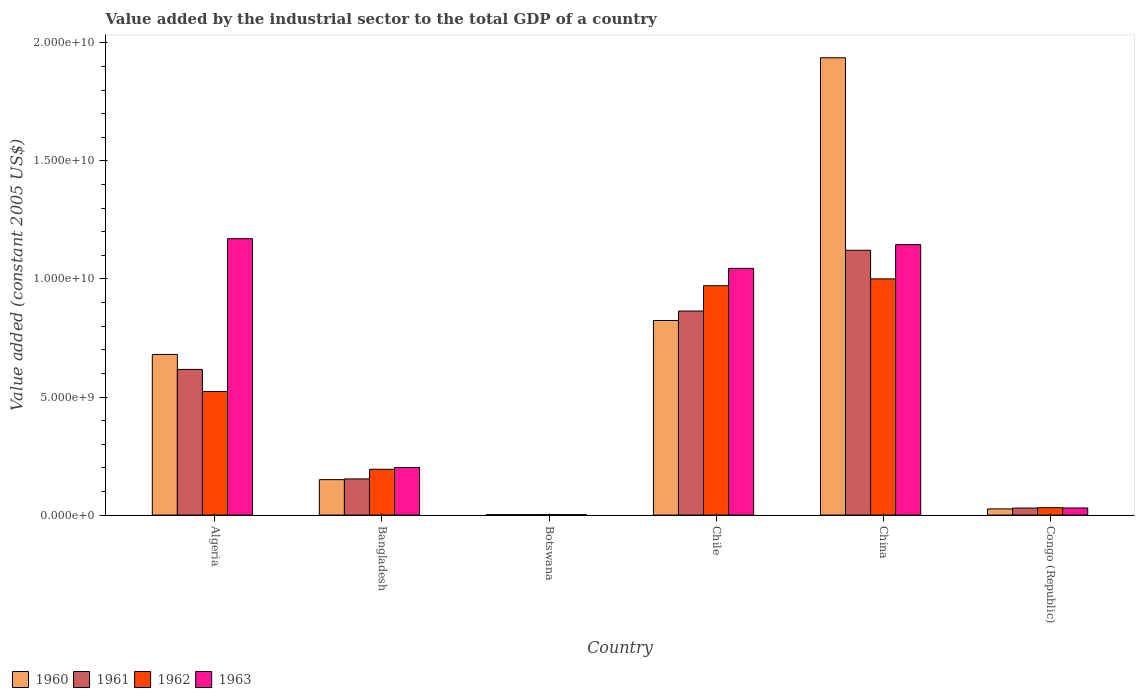How many groups of bars are there?
Provide a succinct answer. 6. Are the number of bars per tick equal to the number of legend labels?
Your answer should be very brief. Yes. Are the number of bars on each tick of the X-axis equal?
Keep it short and to the point. Yes. What is the label of the 2nd group of bars from the left?
Provide a succinct answer. Bangladesh. In how many cases, is the number of bars for a given country not equal to the number of legend labels?
Your response must be concise. 0. What is the value added by the industrial sector in 1961 in Congo (Republic)?
Make the answer very short. 2.98e+08. Across all countries, what is the maximum value added by the industrial sector in 1961?
Offer a very short reply. 1.12e+1. Across all countries, what is the minimum value added by the industrial sector in 1962?
Ensure brevity in your answer.  1.98e+07. In which country was the value added by the industrial sector in 1961 minimum?
Your answer should be very brief. Botswana. What is the total value added by the industrial sector in 1962 in the graph?
Your answer should be compact. 2.72e+1. What is the difference between the value added by the industrial sector in 1961 in Bangladesh and that in Chile?
Your answer should be compact. -7.11e+09. What is the difference between the value added by the industrial sector in 1963 in Botswana and the value added by the industrial sector in 1961 in Congo (Republic)?
Ensure brevity in your answer.  -2.79e+08. What is the average value added by the industrial sector in 1960 per country?
Your answer should be compact. 6.03e+09. What is the difference between the value added by the industrial sector of/in 1962 and value added by the industrial sector of/in 1963 in China?
Offer a very short reply. -1.45e+09. What is the ratio of the value added by the industrial sector in 1961 in Chile to that in China?
Offer a very short reply. 0.77. What is the difference between the highest and the second highest value added by the industrial sector in 1961?
Keep it short and to the point. -2.47e+09. What is the difference between the highest and the lowest value added by the industrial sector in 1962?
Offer a very short reply. 9.98e+09. In how many countries, is the value added by the industrial sector in 1961 greater than the average value added by the industrial sector in 1961 taken over all countries?
Provide a succinct answer. 3. Is it the case that in every country, the sum of the value added by the industrial sector in 1961 and value added by the industrial sector in 1962 is greater than the sum of value added by the industrial sector in 1963 and value added by the industrial sector in 1960?
Offer a very short reply. No. Is it the case that in every country, the sum of the value added by the industrial sector in 1961 and value added by the industrial sector in 1962 is greater than the value added by the industrial sector in 1960?
Your response must be concise. Yes. How many bars are there?
Provide a succinct answer. 24. How many countries are there in the graph?
Your response must be concise. 6. What is the difference between two consecutive major ticks on the Y-axis?
Ensure brevity in your answer.  5.00e+09. Does the graph contain any zero values?
Keep it short and to the point. No. Does the graph contain grids?
Your answer should be compact. No. How are the legend labels stacked?
Keep it short and to the point. Horizontal. What is the title of the graph?
Your response must be concise. Value added by the industrial sector to the total GDP of a country. What is the label or title of the Y-axis?
Keep it short and to the point. Value added (constant 2005 US$). What is the Value added (constant 2005 US$) of 1960 in Algeria?
Give a very brief answer. 6.80e+09. What is the Value added (constant 2005 US$) in 1961 in Algeria?
Your answer should be compact. 6.17e+09. What is the Value added (constant 2005 US$) in 1962 in Algeria?
Your response must be concise. 5.23e+09. What is the Value added (constant 2005 US$) in 1963 in Algeria?
Your response must be concise. 1.17e+1. What is the Value added (constant 2005 US$) in 1960 in Bangladesh?
Offer a terse response. 1.50e+09. What is the Value added (constant 2005 US$) in 1961 in Bangladesh?
Your answer should be compact. 1.53e+09. What is the Value added (constant 2005 US$) in 1962 in Bangladesh?
Your response must be concise. 1.94e+09. What is the Value added (constant 2005 US$) in 1963 in Bangladesh?
Your answer should be compact. 2.01e+09. What is the Value added (constant 2005 US$) of 1960 in Botswana?
Ensure brevity in your answer.  1.96e+07. What is the Value added (constant 2005 US$) in 1961 in Botswana?
Give a very brief answer. 1.92e+07. What is the Value added (constant 2005 US$) in 1962 in Botswana?
Your answer should be compact. 1.98e+07. What is the Value added (constant 2005 US$) in 1963 in Botswana?
Give a very brief answer. 1.83e+07. What is the Value added (constant 2005 US$) of 1960 in Chile?
Your answer should be compact. 8.24e+09. What is the Value added (constant 2005 US$) in 1961 in Chile?
Provide a succinct answer. 8.64e+09. What is the Value added (constant 2005 US$) in 1962 in Chile?
Ensure brevity in your answer.  9.71e+09. What is the Value added (constant 2005 US$) in 1963 in Chile?
Make the answer very short. 1.04e+1. What is the Value added (constant 2005 US$) of 1960 in China?
Give a very brief answer. 1.94e+1. What is the Value added (constant 2005 US$) of 1961 in China?
Your response must be concise. 1.12e+1. What is the Value added (constant 2005 US$) of 1962 in China?
Your answer should be compact. 1.00e+1. What is the Value added (constant 2005 US$) in 1963 in China?
Provide a short and direct response. 1.15e+1. What is the Value added (constant 2005 US$) in 1960 in Congo (Republic)?
Make the answer very short. 2.61e+08. What is the Value added (constant 2005 US$) in 1961 in Congo (Republic)?
Offer a terse response. 2.98e+08. What is the Value added (constant 2005 US$) of 1962 in Congo (Republic)?
Ensure brevity in your answer.  3.12e+08. What is the Value added (constant 2005 US$) of 1963 in Congo (Republic)?
Offer a terse response. 3.00e+08. Across all countries, what is the maximum Value added (constant 2005 US$) of 1960?
Keep it short and to the point. 1.94e+1. Across all countries, what is the maximum Value added (constant 2005 US$) in 1961?
Offer a very short reply. 1.12e+1. Across all countries, what is the maximum Value added (constant 2005 US$) in 1962?
Offer a very short reply. 1.00e+1. Across all countries, what is the maximum Value added (constant 2005 US$) of 1963?
Your answer should be compact. 1.17e+1. Across all countries, what is the minimum Value added (constant 2005 US$) in 1960?
Ensure brevity in your answer.  1.96e+07. Across all countries, what is the minimum Value added (constant 2005 US$) of 1961?
Your answer should be compact. 1.92e+07. Across all countries, what is the minimum Value added (constant 2005 US$) of 1962?
Your answer should be compact. 1.98e+07. Across all countries, what is the minimum Value added (constant 2005 US$) in 1963?
Your answer should be very brief. 1.83e+07. What is the total Value added (constant 2005 US$) in 1960 in the graph?
Make the answer very short. 3.62e+1. What is the total Value added (constant 2005 US$) in 1961 in the graph?
Make the answer very short. 2.79e+1. What is the total Value added (constant 2005 US$) of 1962 in the graph?
Offer a terse response. 2.72e+1. What is the total Value added (constant 2005 US$) in 1963 in the graph?
Your response must be concise. 3.59e+1. What is the difference between the Value added (constant 2005 US$) in 1960 in Algeria and that in Bangladesh?
Your answer should be compact. 5.30e+09. What is the difference between the Value added (constant 2005 US$) in 1961 in Algeria and that in Bangladesh?
Your answer should be very brief. 4.64e+09. What is the difference between the Value added (constant 2005 US$) in 1962 in Algeria and that in Bangladesh?
Your answer should be very brief. 3.29e+09. What is the difference between the Value added (constant 2005 US$) in 1963 in Algeria and that in Bangladesh?
Offer a very short reply. 9.69e+09. What is the difference between the Value added (constant 2005 US$) of 1960 in Algeria and that in Botswana?
Provide a succinct answer. 6.78e+09. What is the difference between the Value added (constant 2005 US$) in 1961 in Algeria and that in Botswana?
Your response must be concise. 6.15e+09. What is the difference between the Value added (constant 2005 US$) of 1962 in Algeria and that in Botswana?
Your answer should be very brief. 5.21e+09. What is the difference between the Value added (constant 2005 US$) in 1963 in Algeria and that in Botswana?
Provide a succinct answer. 1.17e+1. What is the difference between the Value added (constant 2005 US$) of 1960 in Algeria and that in Chile?
Offer a terse response. -1.44e+09. What is the difference between the Value added (constant 2005 US$) of 1961 in Algeria and that in Chile?
Make the answer very short. -2.47e+09. What is the difference between the Value added (constant 2005 US$) in 1962 in Algeria and that in Chile?
Offer a very short reply. -4.48e+09. What is the difference between the Value added (constant 2005 US$) in 1963 in Algeria and that in Chile?
Your answer should be compact. 1.26e+09. What is the difference between the Value added (constant 2005 US$) of 1960 in Algeria and that in China?
Offer a very short reply. -1.26e+1. What is the difference between the Value added (constant 2005 US$) in 1961 in Algeria and that in China?
Ensure brevity in your answer.  -5.05e+09. What is the difference between the Value added (constant 2005 US$) in 1962 in Algeria and that in China?
Ensure brevity in your answer.  -4.77e+09. What is the difference between the Value added (constant 2005 US$) of 1963 in Algeria and that in China?
Provide a succinct answer. 2.51e+08. What is the difference between the Value added (constant 2005 US$) of 1960 in Algeria and that in Congo (Republic)?
Your answer should be compact. 6.54e+09. What is the difference between the Value added (constant 2005 US$) of 1961 in Algeria and that in Congo (Republic)?
Make the answer very short. 5.87e+09. What is the difference between the Value added (constant 2005 US$) in 1962 in Algeria and that in Congo (Republic)?
Your response must be concise. 4.92e+09. What is the difference between the Value added (constant 2005 US$) in 1963 in Algeria and that in Congo (Republic)?
Keep it short and to the point. 1.14e+1. What is the difference between the Value added (constant 2005 US$) of 1960 in Bangladesh and that in Botswana?
Offer a very short reply. 1.48e+09. What is the difference between the Value added (constant 2005 US$) in 1961 in Bangladesh and that in Botswana?
Your answer should be very brief. 1.51e+09. What is the difference between the Value added (constant 2005 US$) in 1962 in Bangladesh and that in Botswana?
Make the answer very short. 1.92e+09. What is the difference between the Value added (constant 2005 US$) of 1963 in Bangladesh and that in Botswana?
Your response must be concise. 2.00e+09. What is the difference between the Value added (constant 2005 US$) in 1960 in Bangladesh and that in Chile?
Provide a short and direct response. -6.74e+09. What is the difference between the Value added (constant 2005 US$) in 1961 in Bangladesh and that in Chile?
Your response must be concise. -7.11e+09. What is the difference between the Value added (constant 2005 US$) in 1962 in Bangladesh and that in Chile?
Make the answer very short. -7.77e+09. What is the difference between the Value added (constant 2005 US$) of 1963 in Bangladesh and that in Chile?
Offer a terse response. -8.43e+09. What is the difference between the Value added (constant 2005 US$) in 1960 in Bangladesh and that in China?
Your answer should be compact. -1.79e+1. What is the difference between the Value added (constant 2005 US$) of 1961 in Bangladesh and that in China?
Provide a short and direct response. -9.68e+09. What is the difference between the Value added (constant 2005 US$) of 1962 in Bangladesh and that in China?
Offer a terse response. -8.06e+09. What is the difference between the Value added (constant 2005 US$) in 1963 in Bangladesh and that in China?
Keep it short and to the point. -9.44e+09. What is the difference between the Value added (constant 2005 US$) in 1960 in Bangladesh and that in Congo (Republic)?
Your answer should be compact. 1.24e+09. What is the difference between the Value added (constant 2005 US$) of 1961 in Bangladesh and that in Congo (Republic)?
Offer a terse response. 1.23e+09. What is the difference between the Value added (constant 2005 US$) of 1962 in Bangladesh and that in Congo (Republic)?
Offer a very short reply. 1.63e+09. What is the difference between the Value added (constant 2005 US$) of 1963 in Bangladesh and that in Congo (Republic)?
Offer a very short reply. 1.71e+09. What is the difference between the Value added (constant 2005 US$) of 1960 in Botswana and that in Chile?
Provide a short and direct response. -8.22e+09. What is the difference between the Value added (constant 2005 US$) of 1961 in Botswana and that in Chile?
Your answer should be compact. -8.62e+09. What is the difference between the Value added (constant 2005 US$) of 1962 in Botswana and that in Chile?
Your response must be concise. -9.69e+09. What is the difference between the Value added (constant 2005 US$) of 1963 in Botswana and that in Chile?
Offer a terse response. -1.04e+1. What is the difference between the Value added (constant 2005 US$) in 1960 in Botswana and that in China?
Keep it short and to the point. -1.93e+1. What is the difference between the Value added (constant 2005 US$) in 1961 in Botswana and that in China?
Give a very brief answer. -1.12e+1. What is the difference between the Value added (constant 2005 US$) of 1962 in Botswana and that in China?
Offer a terse response. -9.98e+09. What is the difference between the Value added (constant 2005 US$) in 1963 in Botswana and that in China?
Make the answer very short. -1.14e+1. What is the difference between the Value added (constant 2005 US$) in 1960 in Botswana and that in Congo (Republic)?
Make the answer very short. -2.42e+08. What is the difference between the Value added (constant 2005 US$) of 1961 in Botswana and that in Congo (Republic)?
Offer a very short reply. -2.78e+08. What is the difference between the Value added (constant 2005 US$) of 1962 in Botswana and that in Congo (Republic)?
Your response must be concise. -2.93e+08. What is the difference between the Value added (constant 2005 US$) in 1963 in Botswana and that in Congo (Republic)?
Your answer should be compact. -2.81e+08. What is the difference between the Value added (constant 2005 US$) of 1960 in Chile and that in China?
Offer a very short reply. -1.11e+1. What is the difference between the Value added (constant 2005 US$) of 1961 in Chile and that in China?
Give a very brief answer. -2.57e+09. What is the difference between the Value added (constant 2005 US$) in 1962 in Chile and that in China?
Give a very brief answer. -2.92e+08. What is the difference between the Value added (constant 2005 US$) of 1963 in Chile and that in China?
Your answer should be very brief. -1.01e+09. What is the difference between the Value added (constant 2005 US$) of 1960 in Chile and that in Congo (Republic)?
Your answer should be very brief. 7.98e+09. What is the difference between the Value added (constant 2005 US$) in 1961 in Chile and that in Congo (Republic)?
Offer a very short reply. 8.34e+09. What is the difference between the Value added (constant 2005 US$) of 1962 in Chile and that in Congo (Republic)?
Ensure brevity in your answer.  9.40e+09. What is the difference between the Value added (constant 2005 US$) of 1963 in Chile and that in Congo (Republic)?
Ensure brevity in your answer.  1.01e+1. What is the difference between the Value added (constant 2005 US$) of 1960 in China and that in Congo (Republic)?
Provide a succinct answer. 1.91e+1. What is the difference between the Value added (constant 2005 US$) of 1961 in China and that in Congo (Republic)?
Ensure brevity in your answer.  1.09e+1. What is the difference between the Value added (constant 2005 US$) of 1962 in China and that in Congo (Republic)?
Give a very brief answer. 9.69e+09. What is the difference between the Value added (constant 2005 US$) of 1963 in China and that in Congo (Republic)?
Make the answer very short. 1.12e+1. What is the difference between the Value added (constant 2005 US$) in 1960 in Algeria and the Value added (constant 2005 US$) in 1961 in Bangladesh?
Give a very brief answer. 5.27e+09. What is the difference between the Value added (constant 2005 US$) in 1960 in Algeria and the Value added (constant 2005 US$) in 1962 in Bangladesh?
Ensure brevity in your answer.  4.86e+09. What is the difference between the Value added (constant 2005 US$) of 1960 in Algeria and the Value added (constant 2005 US$) of 1963 in Bangladesh?
Provide a short and direct response. 4.79e+09. What is the difference between the Value added (constant 2005 US$) of 1961 in Algeria and the Value added (constant 2005 US$) of 1962 in Bangladesh?
Ensure brevity in your answer.  4.23e+09. What is the difference between the Value added (constant 2005 US$) of 1961 in Algeria and the Value added (constant 2005 US$) of 1963 in Bangladesh?
Make the answer very short. 4.15e+09. What is the difference between the Value added (constant 2005 US$) of 1962 in Algeria and the Value added (constant 2005 US$) of 1963 in Bangladesh?
Your answer should be very brief. 3.22e+09. What is the difference between the Value added (constant 2005 US$) of 1960 in Algeria and the Value added (constant 2005 US$) of 1961 in Botswana?
Ensure brevity in your answer.  6.78e+09. What is the difference between the Value added (constant 2005 US$) of 1960 in Algeria and the Value added (constant 2005 US$) of 1962 in Botswana?
Keep it short and to the point. 6.78e+09. What is the difference between the Value added (constant 2005 US$) of 1960 in Algeria and the Value added (constant 2005 US$) of 1963 in Botswana?
Offer a terse response. 6.78e+09. What is the difference between the Value added (constant 2005 US$) of 1961 in Algeria and the Value added (constant 2005 US$) of 1962 in Botswana?
Provide a short and direct response. 6.15e+09. What is the difference between the Value added (constant 2005 US$) in 1961 in Algeria and the Value added (constant 2005 US$) in 1963 in Botswana?
Provide a short and direct response. 6.15e+09. What is the difference between the Value added (constant 2005 US$) in 1962 in Algeria and the Value added (constant 2005 US$) in 1963 in Botswana?
Your answer should be compact. 5.21e+09. What is the difference between the Value added (constant 2005 US$) in 1960 in Algeria and the Value added (constant 2005 US$) in 1961 in Chile?
Make the answer very short. -1.84e+09. What is the difference between the Value added (constant 2005 US$) in 1960 in Algeria and the Value added (constant 2005 US$) in 1962 in Chile?
Ensure brevity in your answer.  -2.91e+09. What is the difference between the Value added (constant 2005 US$) in 1960 in Algeria and the Value added (constant 2005 US$) in 1963 in Chile?
Offer a very short reply. -3.65e+09. What is the difference between the Value added (constant 2005 US$) in 1961 in Algeria and the Value added (constant 2005 US$) in 1962 in Chile?
Keep it short and to the point. -3.54e+09. What is the difference between the Value added (constant 2005 US$) of 1961 in Algeria and the Value added (constant 2005 US$) of 1963 in Chile?
Your answer should be very brief. -4.28e+09. What is the difference between the Value added (constant 2005 US$) in 1962 in Algeria and the Value added (constant 2005 US$) in 1963 in Chile?
Provide a short and direct response. -5.22e+09. What is the difference between the Value added (constant 2005 US$) in 1960 in Algeria and the Value added (constant 2005 US$) in 1961 in China?
Provide a short and direct response. -4.41e+09. What is the difference between the Value added (constant 2005 US$) of 1960 in Algeria and the Value added (constant 2005 US$) of 1962 in China?
Ensure brevity in your answer.  -3.20e+09. What is the difference between the Value added (constant 2005 US$) in 1960 in Algeria and the Value added (constant 2005 US$) in 1963 in China?
Keep it short and to the point. -4.65e+09. What is the difference between the Value added (constant 2005 US$) in 1961 in Algeria and the Value added (constant 2005 US$) in 1962 in China?
Offer a terse response. -3.83e+09. What is the difference between the Value added (constant 2005 US$) in 1961 in Algeria and the Value added (constant 2005 US$) in 1963 in China?
Provide a succinct answer. -5.28e+09. What is the difference between the Value added (constant 2005 US$) of 1962 in Algeria and the Value added (constant 2005 US$) of 1963 in China?
Ensure brevity in your answer.  -6.22e+09. What is the difference between the Value added (constant 2005 US$) of 1960 in Algeria and the Value added (constant 2005 US$) of 1961 in Congo (Republic)?
Offer a very short reply. 6.50e+09. What is the difference between the Value added (constant 2005 US$) in 1960 in Algeria and the Value added (constant 2005 US$) in 1962 in Congo (Republic)?
Ensure brevity in your answer.  6.49e+09. What is the difference between the Value added (constant 2005 US$) of 1960 in Algeria and the Value added (constant 2005 US$) of 1963 in Congo (Republic)?
Your answer should be compact. 6.50e+09. What is the difference between the Value added (constant 2005 US$) in 1961 in Algeria and the Value added (constant 2005 US$) in 1962 in Congo (Republic)?
Provide a succinct answer. 5.86e+09. What is the difference between the Value added (constant 2005 US$) in 1961 in Algeria and the Value added (constant 2005 US$) in 1963 in Congo (Republic)?
Ensure brevity in your answer.  5.87e+09. What is the difference between the Value added (constant 2005 US$) of 1962 in Algeria and the Value added (constant 2005 US$) of 1963 in Congo (Republic)?
Provide a succinct answer. 4.93e+09. What is the difference between the Value added (constant 2005 US$) in 1960 in Bangladesh and the Value added (constant 2005 US$) in 1961 in Botswana?
Offer a very short reply. 1.48e+09. What is the difference between the Value added (constant 2005 US$) of 1960 in Bangladesh and the Value added (constant 2005 US$) of 1962 in Botswana?
Your answer should be compact. 1.48e+09. What is the difference between the Value added (constant 2005 US$) of 1960 in Bangladesh and the Value added (constant 2005 US$) of 1963 in Botswana?
Provide a short and direct response. 1.48e+09. What is the difference between the Value added (constant 2005 US$) of 1961 in Bangladesh and the Value added (constant 2005 US$) of 1962 in Botswana?
Ensure brevity in your answer.  1.51e+09. What is the difference between the Value added (constant 2005 US$) of 1961 in Bangladesh and the Value added (constant 2005 US$) of 1963 in Botswana?
Provide a succinct answer. 1.51e+09. What is the difference between the Value added (constant 2005 US$) in 1962 in Bangladesh and the Value added (constant 2005 US$) in 1963 in Botswana?
Offer a very short reply. 1.92e+09. What is the difference between the Value added (constant 2005 US$) of 1960 in Bangladesh and the Value added (constant 2005 US$) of 1961 in Chile?
Provide a succinct answer. -7.14e+09. What is the difference between the Value added (constant 2005 US$) of 1960 in Bangladesh and the Value added (constant 2005 US$) of 1962 in Chile?
Keep it short and to the point. -8.21e+09. What is the difference between the Value added (constant 2005 US$) of 1960 in Bangladesh and the Value added (constant 2005 US$) of 1963 in Chile?
Provide a succinct answer. -8.95e+09. What is the difference between the Value added (constant 2005 US$) of 1961 in Bangladesh and the Value added (constant 2005 US$) of 1962 in Chile?
Your answer should be very brief. -8.18e+09. What is the difference between the Value added (constant 2005 US$) in 1961 in Bangladesh and the Value added (constant 2005 US$) in 1963 in Chile?
Make the answer very short. -8.92e+09. What is the difference between the Value added (constant 2005 US$) in 1962 in Bangladesh and the Value added (constant 2005 US$) in 1963 in Chile?
Ensure brevity in your answer.  -8.51e+09. What is the difference between the Value added (constant 2005 US$) in 1960 in Bangladesh and the Value added (constant 2005 US$) in 1961 in China?
Offer a terse response. -9.71e+09. What is the difference between the Value added (constant 2005 US$) of 1960 in Bangladesh and the Value added (constant 2005 US$) of 1962 in China?
Your answer should be very brief. -8.50e+09. What is the difference between the Value added (constant 2005 US$) in 1960 in Bangladesh and the Value added (constant 2005 US$) in 1963 in China?
Provide a short and direct response. -9.95e+09. What is the difference between the Value added (constant 2005 US$) in 1961 in Bangladesh and the Value added (constant 2005 US$) in 1962 in China?
Your response must be concise. -8.47e+09. What is the difference between the Value added (constant 2005 US$) in 1961 in Bangladesh and the Value added (constant 2005 US$) in 1963 in China?
Your answer should be compact. -9.92e+09. What is the difference between the Value added (constant 2005 US$) in 1962 in Bangladesh and the Value added (constant 2005 US$) in 1963 in China?
Your answer should be compact. -9.51e+09. What is the difference between the Value added (constant 2005 US$) in 1960 in Bangladesh and the Value added (constant 2005 US$) in 1961 in Congo (Republic)?
Your answer should be compact. 1.20e+09. What is the difference between the Value added (constant 2005 US$) in 1960 in Bangladesh and the Value added (constant 2005 US$) in 1962 in Congo (Republic)?
Give a very brief answer. 1.19e+09. What is the difference between the Value added (constant 2005 US$) in 1960 in Bangladesh and the Value added (constant 2005 US$) in 1963 in Congo (Republic)?
Give a very brief answer. 1.20e+09. What is the difference between the Value added (constant 2005 US$) in 1961 in Bangladesh and the Value added (constant 2005 US$) in 1962 in Congo (Republic)?
Ensure brevity in your answer.  1.22e+09. What is the difference between the Value added (constant 2005 US$) of 1961 in Bangladesh and the Value added (constant 2005 US$) of 1963 in Congo (Republic)?
Keep it short and to the point. 1.23e+09. What is the difference between the Value added (constant 2005 US$) in 1962 in Bangladesh and the Value added (constant 2005 US$) in 1963 in Congo (Republic)?
Your answer should be compact. 1.64e+09. What is the difference between the Value added (constant 2005 US$) in 1960 in Botswana and the Value added (constant 2005 US$) in 1961 in Chile?
Your answer should be compact. -8.62e+09. What is the difference between the Value added (constant 2005 US$) of 1960 in Botswana and the Value added (constant 2005 US$) of 1962 in Chile?
Provide a succinct answer. -9.69e+09. What is the difference between the Value added (constant 2005 US$) in 1960 in Botswana and the Value added (constant 2005 US$) in 1963 in Chile?
Provide a succinct answer. -1.04e+1. What is the difference between the Value added (constant 2005 US$) of 1961 in Botswana and the Value added (constant 2005 US$) of 1962 in Chile?
Provide a succinct answer. -9.69e+09. What is the difference between the Value added (constant 2005 US$) of 1961 in Botswana and the Value added (constant 2005 US$) of 1963 in Chile?
Keep it short and to the point. -1.04e+1. What is the difference between the Value added (constant 2005 US$) in 1962 in Botswana and the Value added (constant 2005 US$) in 1963 in Chile?
Offer a very short reply. -1.04e+1. What is the difference between the Value added (constant 2005 US$) in 1960 in Botswana and the Value added (constant 2005 US$) in 1961 in China?
Offer a terse response. -1.12e+1. What is the difference between the Value added (constant 2005 US$) in 1960 in Botswana and the Value added (constant 2005 US$) in 1962 in China?
Ensure brevity in your answer.  -9.98e+09. What is the difference between the Value added (constant 2005 US$) in 1960 in Botswana and the Value added (constant 2005 US$) in 1963 in China?
Give a very brief answer. -1.14e+1. What is the difference between the Value added (constant 2005 US$) of 1961 in Botswana and the Value added (constant 2005 US$) of 1962 in China?
Give a very brief answer. -9.98e+09. What is the difference between the Value added (constant 2005 US$) in 1961 in Botswana and the Value added (constant 2005 US$) in 1963 in China?
Provide a short and direct response. -1.14e+1. What is the difference between the Value added (constant 2005 US$) of 1962 in Botswana and the Value added (constant 2005 US$) of 1963 in China?
Give a very brief answer. -1.14e+1. What is the difference between the Value added (constant 2005 US$) of 1960 in Botswana and the Value added (constant 2005 US$) of 1961 in Congo (Republic)?
Keep it short and to the point. -2.78e+08. What is the difference between the Value added (constant 2005 US$) of 1960 in Botswana and the Value added (constant 2005 US$) of 1962 in Congo (Republic)?
Offer a terse response. -2.93e+08. What is the difference between the Value added (constant 2005 US$) of 1960 in Botswana and the Value added (constant 2005 US$) of 1963 in Congo (Republic)?
Keep it short and to the point. -2.80e+08. What is the difference between the Value added (constant 2005 US$) of 1961 in Botswana and the Value added (constant 2005 US$) of 1962 in Congo (Republic)?
Give a very brief answer. -2.93e+08. What is the difference between the Value added (constant 2005 US$) in 1961 in Botswana and the Value added (constant 2005 US$) in 1963 in Congo (Republic)?
Make the answer very short. -2.81e+08. What is the difference between the Value added (constant 2005 US$) of 1962 in Botswana and the Value added (constant 2005 US$) of 1963 in Congo (Republic)?
Make the answer very short. -2.80e+08. What is the difference between the Value added (constant 2005 US$) in 1960 in Chile and the Value added (constant 2005 US$) in 1961 in China?
Offer a terse response. -2.97e+09. What is the difference between the Value added (constant 2005 US$) of 1960 in Chile and the Value added (constant 2005 US$) of 1962 in China?
Provide a succinct answer. -1.76e+09. What is the difference between the Value added (constant 2005 US$) of 1960 in Chile and the Value added (constant 2005 US$) of 1963 in China?
Provide a succinct answer. -3.21e+09. What is the difference between the Value added (constant 2005 US$) in 1961 in Chile and the Value added (constant 2005 US$) in 1962 in China?
Make the answer very short. -1.36e+09. What is the difference between the Value added (constant 2005 US$) in 1961 in Chile and the Value added (constant 2005 US$) in 1963 in China?
Provide a succinct answer. -2.81e+09. What is the difference between the Value added (constant 2005 US$) in 1962 in Chile and the Value added (constant 2005 US$) in 1963 in China?
Keep it short and to the point. -1.74e+09. What is the difference between the Value added (constant 2005 US$) of 1960 in Chile and the Value added (constant 2005 US$) of 1961 in Congo (Republic)?
Your answer should be very brief. 7.94e+09. What is the difference between the Value added (constant 2005 US$) in 1960 in Chile and the Value added (constant 2005 US$) in 1962 in Congo (Republic)?
Keep it short and to the point. 7.93e+09. What is the difference between the Value added (constant 2005 US$) of 1960 in Chile and the Value added (constant 2005 US$) of 1963 in Congo (Republic)?
Make the answer very short. 7.94e+09. What is the difference between the Value added (constant 2005 US$) in 1961 in Chile and the Value added (constant 2005 US$) in 1962 in Congo (Republic)?
Your answer should be compact. 8.33e+09. What is the difference between the Value added (constant 2005 US$) in 1961 in Chile and the Value added (constant 2005 US$) in 1963 in Congo (Republic)?
Make the answer very short. 8.34e+09. What is the difference between the Value added (constant 2005 US$) of 1962 in Chile and the Value added (constant 2005 US$) of 1963 in Congo (Republic)?
Keep it short and to the point. 9.41e+09. What is the difference between the Value added (constant 2005 US$) in 1960 in China and the Value added (constant 2005 US$) in 1961 in Congo (Republic)?
Keep it short and to the point. 1.91e+1. What is the difference between the Value added (constant 2005 US$) of 1960 in China and the Value added (constant 2005 US$) of 1962 in Congo (Republic)?
Your answer should be compact. 1.91e+1. What is the difference between the Value added (constant 2005 US$) in 1960 in China and the Value added (constant 2005 US$) in 1963 in Congo (Republic)?
Provide a succinct answer. 1.91e+1. What is the difference between the Value added (constant 2005 US$) of 1961 in China and the Value added (constant 2005 US$) of 1962 in Congo (Republic)?
Make the answer very short. 1.09e+1. What is the difference between the Value added (constant 2005 US$) of 1961 in China and the Value added (constant 2005 US$) of 1963 in Congo (Republic)?
Offer a very short reply. 1.09e+1. What is the difference between the Value added (constant 2005 US$) in 1962 in China and the Value added (constant 2005 US$) in 1963 in Congo (Republic)?
Your answer should be compact. 9.70e+09. What is the average Value added (constant 2005 US$) of 1960 per country?
Give a very brief answer. 6.03e+09. What is the average Value added (constant 2005 US$) of 1961 per country?
Keep it short and to the point. 4.65e+09. What is the average Value added (constant 2005 US$) of 1962 per country?
Offer a very short reply. 4.54e+09. What is the average Value added (constant 2005 US$) of 1963 per country?
Make the answer very short. 5.99e+09. What is the difference between the Value added (constant 2005 US$) in 1960 and Value added (constant 2005 US$) in 1961 in Algeria?
Your response must be concise. 6.34e+08. What is the difference between the Value added (constant 2005 US$) in 1960 and Value added (constant 2005 US$) in 1962 in Algeria?
Give a very brief answer. 1.57e+09. What is the difference between the Value added (constant 2005 US$) in 1960 and Value added (constant 2005 US$) in 1963 in Algeria?
Your response must be concise. -4.90e+09. What is the difference between the Value added (constant 2005 US$) of 1961 and Value added (constant 2005 US$) of 1962 in Algeria?
Make the answer very short. 9.37e+08. What is the difference between the Value added (constant 2005 US$) of 1961 and Value added (constant 2005 US$) of 1963 in Algeria?
Make the answer very short. -5.54e+09. What is the difference between the Value added (constant 2005 US$) of 1962 and Value added (constant 2005 US$) of 1963 in Algeria?
Your response must be concise. -6.47e+09. What is the difference between the Value added (constant 2005 US$) of 1960 and Value added (constant 2005 US$) of 1961 in Bangladesh?
Your answer should be very brief. -3.05e+07. What is the difference between the Value added (constant 2005 US$) in 1960 and Value added (constant 2005 US$) in 1962 in Bangladesh?
Your answer should be very brief. -4.38e+08. What is the difference between the Value added (constant 2005 US$) in 1960 and Value added (constant 2005 US$) in 1963 in Bangladesh?
Give a very brief answer. -5.14e+08. What is the difference between the Value added (constant 2005 US$) in 1961 and Value added (constant 2005 US$) in 1962 in Bangladesh?
Offer a terse response. -4.08e+08. What is the difference between the Value added (constant 2005 US$) in 1961 and Value added (constant 2005 US$) in 1963 in Bangladesh?
Ensure brevity in your answer.  -4.84e+08. What is the difference between the Value added (constant 2005 US$) of 1962 and Value added (constant 2005 US$) of 1963 in Bangladesh?
Provide a succinct answer. -7.60e+07. What is the difference between the Value added (constant 2005 US$) in 1960 and Value added (constant 2005 US$) in 1961 in Botswana?
Your response must be concise. 4.24e+05. What is the difference between the Value added (constant 2005 US$) in 1960 and Value added (constant 2005 US$) in 1962 in Botswana?
Provide a short and direct response. -2.12e+05. What is the difference between the Value added (constant 2005 US$) of 1960 and Value added (constant 2005 US$) of 1963 in Botswana?
Ensure brevity in your answer.  1.27e+06. What is the difference between the Value added (constant 2005 US$) in 1961 and Value added (constant 2005 US$) in 1962 in Botswana?
Your answer should be very brief. -6.36e+05. What is the difference between the Value added (constant 2005 US$) in 1961 and Value added (constant 2005 US$) in 1963 in Botswana?
Keep it short and to the point. 8.48e+05. What is the difference between the Value added (constant 2005 US$) of 1962 and Value added (constant 2005 US$) of 1963 in Botswana?
Make the answer very short. 1.48e+06. What is the difference between the Value added (constant 2005 US$) of 1960 and Value added (constant 2005 US$) of 1961 in Chile?
Offer a terse response. -4.01e+08. What is the difference between the Value added (constant 2005 US$) of 1960 and Value added (constant 2005 US$) of 1962 in Chile?
Provide a short and direct response. -1.47e+09. What is the difference between the Value added (constant 2005 US$) of 1960 and Value added (constant 2005 US$) of 1963 in Chile?
Offer a terse response. -2.21e+09. What is the difference between the Value added (constant 2005 US$) of 1961 and Value added (constant 2005 US$) of 1962 in Chile?
Your response must be concise. -1.07e+09. What is the difference between the Value added (constant 2005 US$) of 1961 and Value added (constant 2005 US$) of 1963 in Chile?
Provide a succinct answer. -1.81e+09. What is the difference between the Value added (constant 2005 US$) in 1962 and Value added (constant 2005 US$) in 1963 in Chile?
Your answer should be very brief. -7.37e+08. What is the difference between the Value added (constant 2005 US$) of 1960 and Value added (constant 2005 US$) of 1961 in China?
Provide a succinct answer. 8.15e+09. What is the difference between the Value added (constant 2005 US$) of 1960 and Value added (constant 2005 US$) of 1962 in China?
Offer a terse response. 9.36e+09. What is the difference between the Value added (constant 2005 US$) of 1960 and Value added (constant 2005 US$) of 1963 in China?
Your answer should be very brief. 7.91e+09. What is the difference between the Value added (constant 2005 US$) in 1961 and Value added (constant 2005 US$) in 1962 in China?
Offer a very short reply. 1.21e+09. What is the difference between the Value added (constant 2005 US$) in 1961 and Value added (constant 2005 US$) in 1963 in China?
Ensure brevity in your answer.  -2.39e+08. What is the difference between the Value added (constant 2005 US$) of 1962 and Value added (constant 2005 US$) of 1963 in China?
Offer a terse response. -1.45e+09. What is the difference between the Value added (constant 2005 US$) in 1960 and Value added (constant 2005 US$) in 1961 in Congo (Republic)?
Provide a short and direct response. -3.63e+07. What is the difference between the Value added (constant 2005 US$) in 1960 and Value added (constant 2005 US$) in 1962 in Congo (Republic)?
Give a very brief answer. -5.10e+07. What is the difference between the Value added (constant 2005 US$) of 1960 and Value added (constant 2005 US$) of 1963 in Congo (Republic)?
Offer a very short reply. -3.84e+07. What is the difference between the Value added (constant 2005 US$) of 1961 and Value added (constant 2005 US$) of 1962 in Congo (Republic)?
Make the answer very short. -1.47e+07. What is the difference between the Value added (constant 2005 US$) of 1961 and Value added (constant 2005 US$) of 1963 in Congo (Republic)?
Your response must be concise. -2.10e+06. What is the difference between the Value added (constant 2005 US$) of 1962 and Value added (constant 2005 US$) of 1963 in Congo (Republic)?
Give a very brief answer. 1.26e+07. What is the ratio of the Value added (constant 2005 US$) of 1960 in Algeria to that in Bangladesh?
Offer a very short reply. 4.53. What is the ratio of the Value added (constant 2005 US$) of 1961 in Algeria to that in Bangladesh?
Your answer should be compact. 4.03. What is the ratio of the Value added (constant 2005 US$) in 1962 in Algeria to that in Bangladesh?
Your response must be concise. 2.7. What is the ratio of the Value added (constant 2005 US$) in 1963 in Algeria to that in Bangladesh?
Offer a terse response. 5.81. What is the ratio of the Value added (constant 2005 US$) of 1960 in Algeria to that in Botswana?
Your answer should be compact. 346.79. What is the ratio of the Value added (constant 2005 US$) in 1961 in Algeria to that in Botswana?
Keep it short and to the point. 321.41. What is the ratio of the Value added (constant 2005 US$) in 1962 in Algeria to that in Botswana?
Your answer should be very brief. 263.85. What is the ratio of the Value added (constant 2005 US$) in 1963 in Algeria to that in Botswana?
Your response must be concise. 638.08. What is the ratio of the Value added (constant 2005 US$) in 1960 in Algeria to that in Chile?
Provide a succinct answer. 0.83. What is the ratio of the Value added (constant 2005 US$) in 1961 in Algeria to that in Chile?
Offer a very short reply. 0.71. What is the ratio of the Value added (constant 2005 US$) in 1962 in Algeria to that in Chile?
Give a very brief answer. 0.54. What is the ratio of the Value added (constant 2005 US$) in 1963 in Algeria to that in Chile?
Offer a very short reply. 1.12. What is the ratio of the Value added (constant 2005 US$) of 1960 in Algeria to that in China?
Provide a succinct answer. 0.35. What is the ratio of the Value added (constant 2005 US$) in 1961 in Algeria to that in China?
Offer a terse response. 0.55. What is the ratio of the Value added (constant 2005 US$) of 1962 in Algeria to that in China?
Your response must be concise. 0.52. What is the ratio of the Value added (constant 2005 US$) of 1963 in Algeria to that in China?
Offer a very short reply. 1.02. What is the ratio of the Value added (constant 2005 US$) in 1960 in Algeria to that in Congo (Republic)?
Your answer should be very brief. 26.02. What is the ratio of the Value added (constant 2005 US$) of 1961 in Algeria to that in Congo (Republic)?
Your answer should be compact. 20.72. What is the ratio of the Value added (constant 2005 US$) of 1962 in Algeria to that in Congo (Republic)?
Your answer should be compact. 16.75. What is the ratio of the Value added (constant 2005 US$) of 1963 in Algeria to that in Congo (Republic)?
Ensure brevity in your answer.  39.05. What is the ratio of the Value added (constant 2005 US$) of 1960 in Bangladesh to that in Botswana?
Your answer should be very brief. 76.48. What is the ratio of the Value added (constant 2005 US$) of 1961 in Bangladesh to that in Botswana?
Provide a succinct answer. 79.76. What is the ratio of the Value added (constant 2005 US$) of 1962 in Bangladesh to that in Botswana?
Keep it short and to the point. 97.78. What is the ratio of the Value added (constant 2005 US$) in 1963 in Bangladesh to that in Botswana?
Make the answer very short. 109.83. What is the ratio of the Value added (constant 2005 US$) of 1960 in Bangladesh to that in Chile?
Provide a short and direct response. 0.18. What is the ratio of the Value added (constant 2005 US$) in 1961 in Bangladesh to that in Chile?
Offer a terse response. 0.18. What is the ratio of the Value added (constant 2005 US$) of 1962 in Bangladesh to that in Chile?
Offer a very short reply. 0.2. What is the ratio of the Value added (constant 2005 US$) of 1963 in Bangladesh to that in Chile?
Your answer should be very brief. 0.19. What is the ratio of the Value added (constant 2005 US$) in 1960 in Bangladesh to that in China?
Make the answer very short. 0.08. What is the ratio of the Value added (constant 2005 US$) of 1961 in Bangladesh to that in China?
Your answer should be very brief. 0.14. What is the ratio of the Value added (constant 2005 US$) in 1962 in Bangladesh to that in China?
Provide a short and direct response. 0.19. What is the ratio of the Value added (constant 2005 US$) of 1963 in Bangladesh to that in China?
Provide a short and direct response. 0.18. What is the ratio of the Value added (constant 2005 US$) of 1960 in Bangladesh to that in Congo (Republic)?
Offer a very short reply. 5.74. What is the ratio of the Value added (constant 2005 US$) of 1961 in Bangladesh to that in Congo (Republic)?
Your response must be concise. 5.14. What is the ratio of the Value added (constant 2005 US$) of 1962 in Bangladesh to that in Congo (Republic)?
Provide a short and direct response. 6.21. What is the ratio of the Value added (constant 2005 US$) in 1963 in Bangladesh to that in Congo (Republic)?
Make the answer very short. 6.72. What is the ratio of the Value added (constant 2005 US$) of 1960 in Botswana to that in Chile?
Make the answer very short. 0. What is the ratio of the Value added (constant 2005 US$) of 1961 in Botswana to that in Chile?
Your answer should be compact. 0. What is the ratio of the Value added (constant 2005 US$) of 1962 in Botswana to that in Chile?
Offer a very short reply. 0. What is the ratio of the Value added (constant 2005 US$) of 1963 in Botswana to that in Chile?
Keep it short and to the point. 0. What is the ratio of the Value added (constant 2005 US$) in 1960 in Botswana to that in China?
Provide a succinct answer. 0. What is the ratio of the Value added (constant 2005 US$) in 1961 in Botswana to that in China?
Offer a terse response. 0. What is the ratio of the Value added (constant 2005 US$) of 1962 in Botswana to that in China?
Offer a terse response. 0. What is the ratio of the Value added (constant 2005 US$) of 1963 in Botswana to that in China?
Make the answer very short. 0. What is the ratio of the Value added (constant 2005 US$) of 1960 in Botswana to that in Congo (Republic)?
Offer a very short reply. 0.07. What is the ratio of the Value added (constant 2005 US$) of 1961 in Botswana to that in Congo (Republic)?
Offer a terse response. 0.06. What is the ratio of the Value added (constant 2005 US$) in 1962 in Botswana to that in Congo (Republic)?
Provide a short and direct response. 0.06. What is the ratio of the Value added (constant 2005 US$) of 1963 in Botswana to that in Congo (Republic)?
Provide a short and direct response. 0.06. What is the ratio of the Value added (constant 2005 US$) in 1960 in Chile to that in China?
Your answer should be very brief. 0.43. What is the ratio of the Value added (constant 2005 US$) in 1961 in Chile to that in China?
Make the answer very short. 0.77. What is the ratio of the Value added (constant 2005 US$) of 1962 in Chile to that in China?
Keep it short and to the point. 0.97. What is the ratio of the Value added (constant 2005 US$) in 1963 in Chile to that in China?
Provide a short and direct response. 0.91. What is the ratio of the Value added (constant 2005 US$) of 1960 in Chile to that in Congo (Republic)?
Give a very brief answer. 31.52. What is the ratio of the Value added (constant 2005 US$) in 1961 in Chile to that in Congo (Republic)?
Provide a succinct answer. 29.03. What is the ratio of the Value added (constant 2005 US$) of 1962 in Chile to that in Congo (Republic)?
Offer a very short reply. 31.09. What is the ratio of the Value added (constant 2005 US$) in 1963 in Chile to that in Congo (Republic)?
Provide a succinct answer. 34.85. What is the ratio of the Value added (constant 2005 US$) in 1960 in China to that in Congo (Republic)?
Your response must be concise. 74.09. What is the ratio of the Value added (constant 2005 US$) in 1961 in China to that in Congo (Republic)?
Keep it short and to the point. 37.67. What is the ratio of the Value added (constant 2005 US$) of 1962 in China to that in Congo (Republic)?
Offer a terse response. 32.02. What is the ratio of the Value added (constant 2005 US$) in 1963 in China to that in Congo (Republic)?
Offer a terse response. 38.21. What is the difference between the highest and the second highest Value added (constant 2005 US$) in 1960?
Your response must be concise. 1.11e+1. What is the difference between the highest and the second highest Value added (constant 2005 US$) in 1961?
Offer a very short reply. 2.57e+09. What is the difference between the highest and the second highest Value added (constant 2005 US$) of 1962?
Make the answer very short. 2.92e+08. What is the difference between the highest and the second highest Value added (constant 2005 US$) of 1963?
Your answer should be compact. 2.51e+08. What is the difference between the highest and the lowest Value added (constant 2005 US$) of 1960?
Your answer should be very brief. 1.93e+1. What is the difference between the highest and the lowest Value added (constant 2005 US$) of 1961?
Your answer should be compact. 1.12e+1. What is the difference between the highest and the lowest Value added (constant 2005 US$) of 1962?
Give a very brief answer. 9.98e+09. What is the difference between the highest and the lowest Value added (constant 2005 US$) of 1963?
Provide a short and direct response. 1.17e+1. 